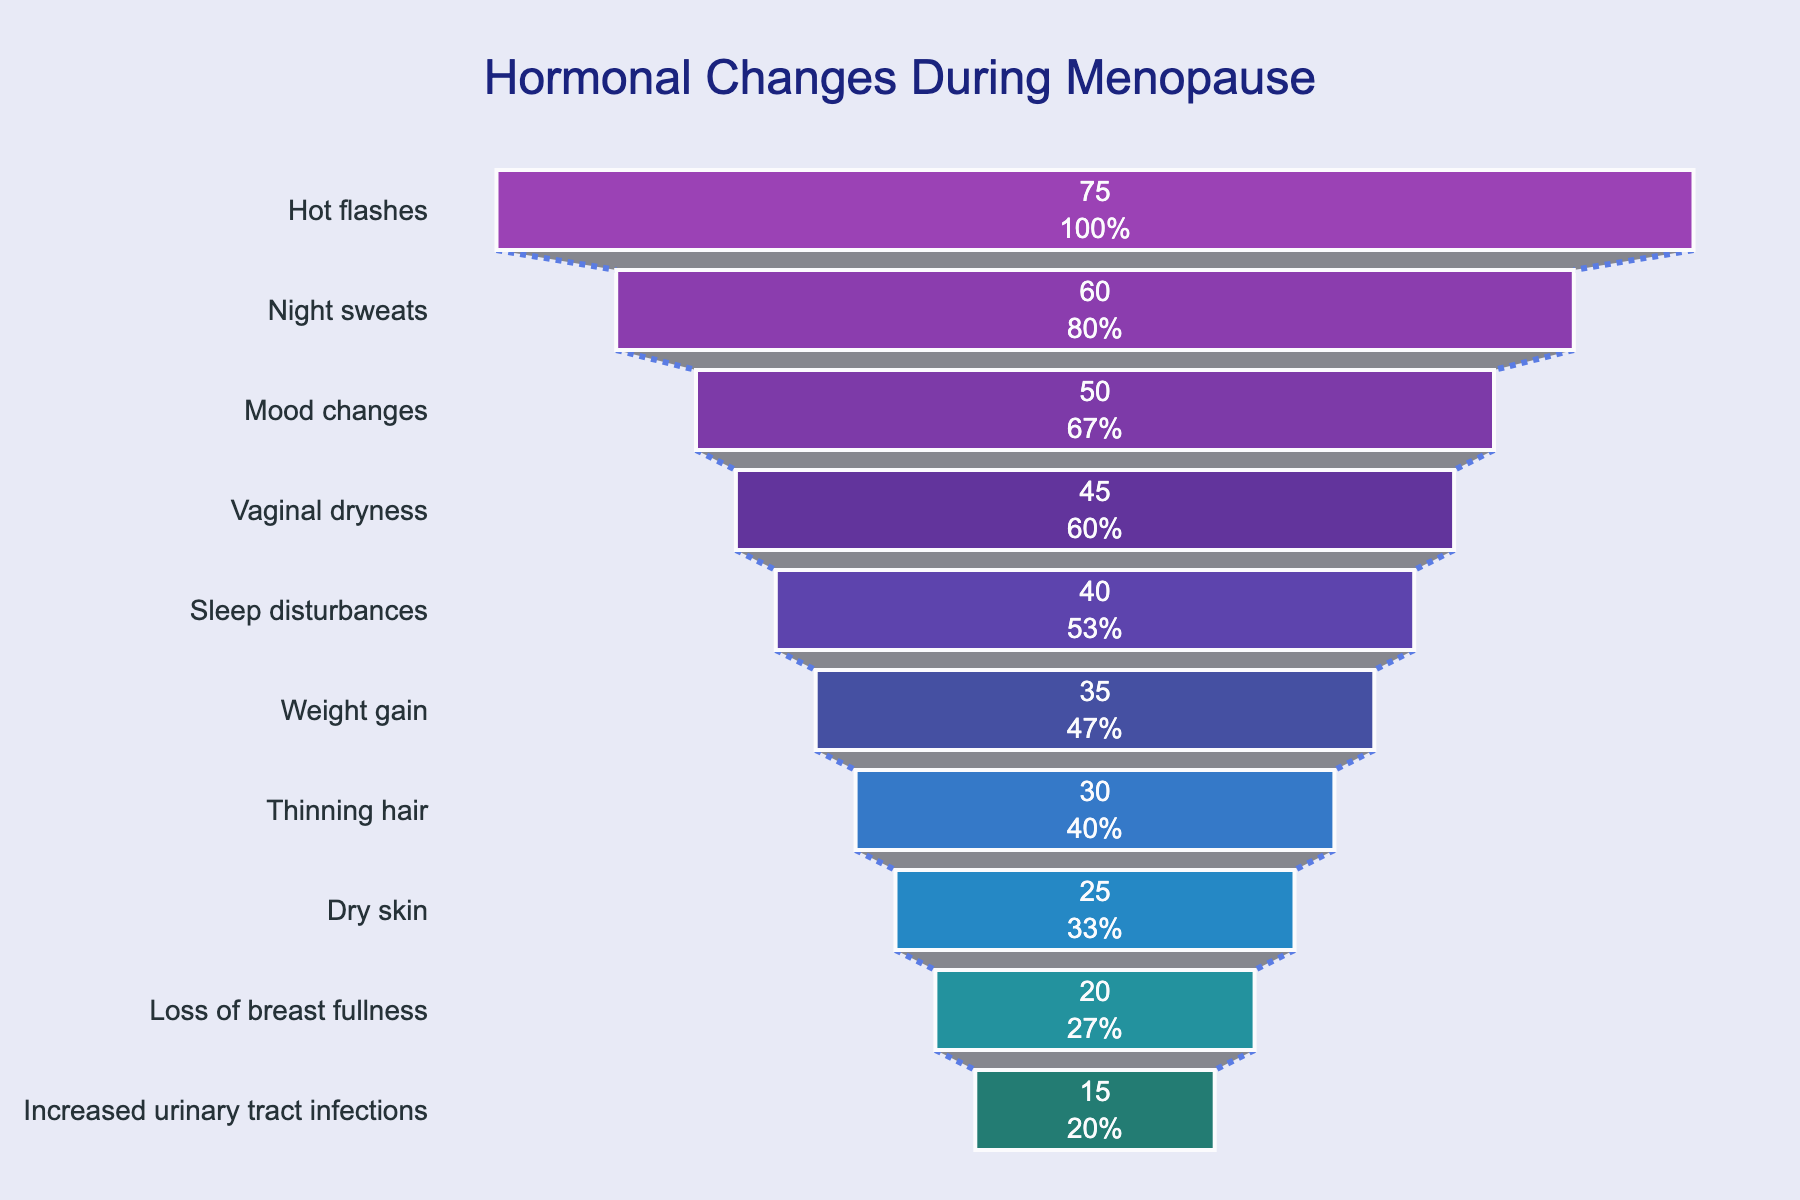What percentage of women experience hot flashes during menopause? The figure lists symptoms and their corresponding percentages. By looking at the listed percentages, hot flashes are experienced by 75% of women during menopause.
Answer: 75% How many symptoms have a percentage of women experiencing them at or above 50%? To determine this, we look at the symptoms where the percentage is 50% or higher. Hot flashes (75%), night sweats (60%), and mood changes (50%) are the symptoms that meet this criterion.
Answer: 3 Which symptom is experienced by the lowest percentage of women? The symptom with the smallest bar in the funnel chart represents the lowest percentage. Increased urinary tract infections have the lowest value at 15%.
Answer: Increased urinary tract infections What is the combined percentage of women experiencing night sweats and sleep disturbances? First, identify the percentages for these symptoms: night sweats (60%) and sleep disturbances (40%). Then, sum these values: 60% + 40% = 100%.
Answer: 100% What is the median percentage of women experiencing the listed symptoms? To find the median, list the percentages in ascending order and find the middle value: 15%, 20%, 25%, 30%, 35%, 40%, 45%, 50%, 60%, 75%. The median value is the average of the 5th and 6th values: (35% + 40%)/2 = 37.5%.
Answer: 37.5% By how much is the percentage of women experiencing dry skin higher than those experiencing increased urinary tract infections? Find the percentages for dry skin (25%) and increased urinary tract infections (15%). Subtract the smaller value from the larger one: 25% - 15% = 10%.
Answer: 10% What percentage of women experience both mood changes and weight gain during menopause? First, find the percentages for mood changes (50%) and weight gain (35%). Then multiply them to find the joint percentage: 50% * 35% = 17.5%. However, note this joint percentage assumes independence, which might not be accurate.
Answer: 17.5% (assuming independence) Which symptom shows a 10% decrease in percentage of women experiencing it compared to vaginal dryness? Find the percentage for vaginal dryness (45%) and subtract 10%: 45% - 10% = 35%. The symptom with 35% is weight gain.
Answer: Weight gain How is the confidence highlighted visually in the chart? The confidence in the data is visually supported by clean, well-defined bars, distinct colors, and marked connectors, implying reliability through consistency and clarity.
Answer: Clean bars, distinct colors, marked connectors 